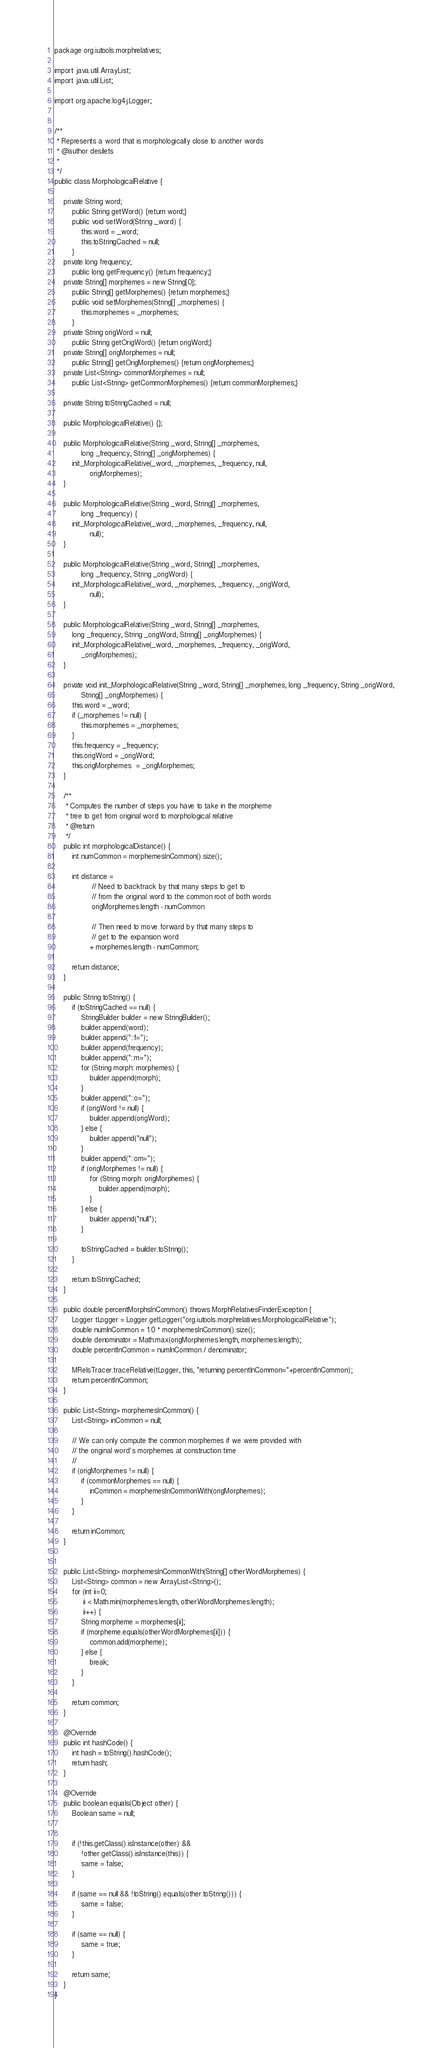Convert code to text. <code><loc_0><loc_0><loc_500><loc_500><_Java_>package org.iutools.morphrelatives;

import java.util.ArrayList;
import java.util.List;

import org.apache.log4j.Logger;


/**
 * Represents a word that is morphologically close to another words
 * @author desilets
 *
 */
public class MorphologicalRelative {
	
	private String word;
		public String getWord() {return word;}
		public void setWord(String _word) {
			this.word = _word;
			this.toStringCached = null;
		}
	private long frequency; 
		public long getFrequency() {return frequency;}
 	private String[] morphemes = new String[0];
 		public String[] getMorphemes() {return morphemes;}
 		public void setMorphemes(String[] _morphemes) {
 			this.morphemes = _morphemes;
		}
	private String origWord = null;
 		public String getOrigWord() {return origWord;}
	private String[] origMorphemes = null;
		public String[] getOrigMorphemes() {return origMorphemes;}
	private List<String> commonMorphemes = null;
		public List<String> getCommonMorphemes() {return commonMorphemes;}
	
	private String toStringCached = null;

	public MorphologicalRelative() {};

	public MorphologicalRelative(String _word, String[] _morphemes,
			long _frequency, String[] _origMorphemes) {
		init_MorphologicalRelative(_word, _morphemes, _frequency, null, 
				origMorphemes);
	}
	
	public MorphologicalRelative(String _word, String[] _morphemes, 
			long _frequency) {
		init_MorphologicalRelative(_word, _morphemes, _frequency, null, 
				null);
	}
	
	public MorphologicalRelative(String _word, String[] _morphemes, 
			long _frequency, String _origWord) {
		init_MorphologicalRelative(_word, _morphemes, _frequency, _origWord, 
				null);
	}
	
	public MorphologicalRelative(String _word, String[] _morphemes, 
		long _frequency, String _origWord, String[] _origMorphemes) {
		init_MorphologicalRelative(_word, _morphemes, _frequency, _origWord, 
			_origMorphemes);
	}

	private void init_MorphologicalRelative(String _word, String[] _morphemes, long _frequency, String _origWord,
			String[] _origMorphemes) {
		this.word = _word;
		if (_morphemes != null) {
			this.morphemes = _morphemes;
		}
		this.frequency = _frequency;
		this.origWord = _origWord;
		this.origMorphemes  = _origMorphemes;
	}

	/**
	 * Computes the number of steps you have to take in the morpheme
	 * tree to get from original word to morphological relative
	 * @return
	 */
	public int morphologicalDistance() {
		int numCommon = morphemesInCommon().size();
		
		int distance =
				 // Need to backtrack by that many steps to get to
				 // from the original word to the common root of both words
				 origMorphemes.length - numCommon
				 
				 // Then need to move forward by that many steps to 
				 // get to the expansion word
				+ morphemes.length - numCommon;
		
		return distance;
	}
	
	public String toString() {
		if (toStringCached == null) {
			StringBuilder builder = new StringBuilder();
			builder.append(word);
			builder.append("::f=");
			builder.append(frequency);
			builder.append("::m=");
			for (String morph: morphemes) {
				builder.append(morph);
			}
			builder.append("::o=");
			if (origWord != null) {
				builder.append(origWord);
			} else {
				builder.append("null");
			}
			builder.append("::om=");
			if (origMorphemes != null) {
				for (String morph: origMorphemes) {
					builder.append(morph);
				}			
			} else {
				builder.append("null");
			}	
			
			toStringCached = builder.toString();
		}
		
		return toStringCached;
	}

	public double percentMorphsInCommon() throws MorphRelativesFinderException {
		Logger tLogger = Logger.getLogger("org.iutools.morphrelatives.MorphologicalRelative");
		double numInCommon = 1.0 * morphemesInCommon().size();
		double denominator = Math.max(origMorphemes.length, morphemes.length);
		double percentInCommon = numInCommon / denominator;

		MRelsTracer.traceRelative(tLogger, this, "returning percentInCommon="+percentInCommon);
		return percentInCommon;
	}

	public List<String> morphemesInCommon() {
		List<String> inCommon = null;
		
		// We can only compute the common morphemes if we were provided with 
		// the original word's morphemes at construction time
		//
		if (origMorphemes != null) {
			if (commonMorphemes == null) {
				inCommon = morphemesInCommonWith(origMorphemes);
			}
		}
		
		return inCommon;
	}

	
	public List<String> morphemesInCommonWith(String[] otherWordMorphemes) {
		List<String> common = new ArrayList<String>();
		for (int ii=0; 
			 ii < Math.min(morphemes.length, otherWordMorphemes.length);
			 ii++) {
			String morpheme = morphemes[ii];
			if (morpheme.equals(otherWordMorphemes[ii])) {
				common.add(morpheme);
			} else {
				break;
			}
		}
		
		return common;
	}
	
	@Override
    public int hashCode() {
        int hash = toString().hashCode();
        return hash;
    }	
	
	@Override
	public boolean equals(Object other) {		
		Boolean same = null;
		
		
		if (!this.getClass().isInstance(other) && 
			!other.getClass().isInstance(this)) {
			same = false;
		}
		
		if (same == null && !toString().equals(other.toString())) {
			same = false;
		}
		
		if (same == null) {
			same = true;
		}
		
		return same;
	}
}
</code> 